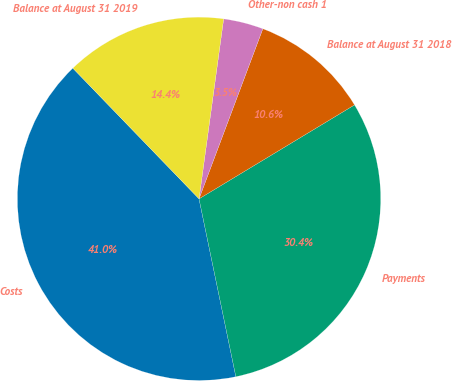Convert chart to OTSL. <chart><loc_0><loc_0><loc_500><loc_500><pie_chart><fcel>Costs<fcel>Payments<fcel>Balance at August 31 2018<fcel>Other-non cash 1<fcel>Balance at August 31 2019<nl><fcel>41.03%<fcel>30.4%<fcel>10.64%<fcel>3.55%<fcel>14.39%<nl></chart> 